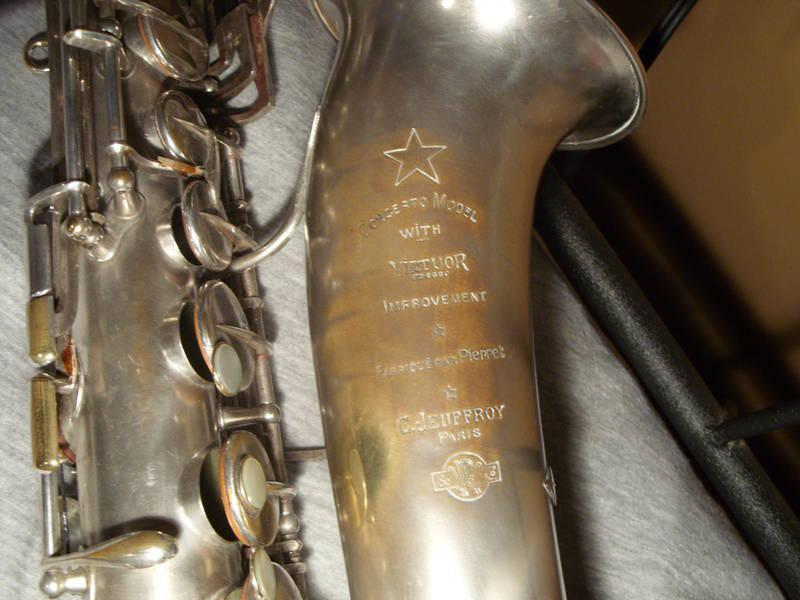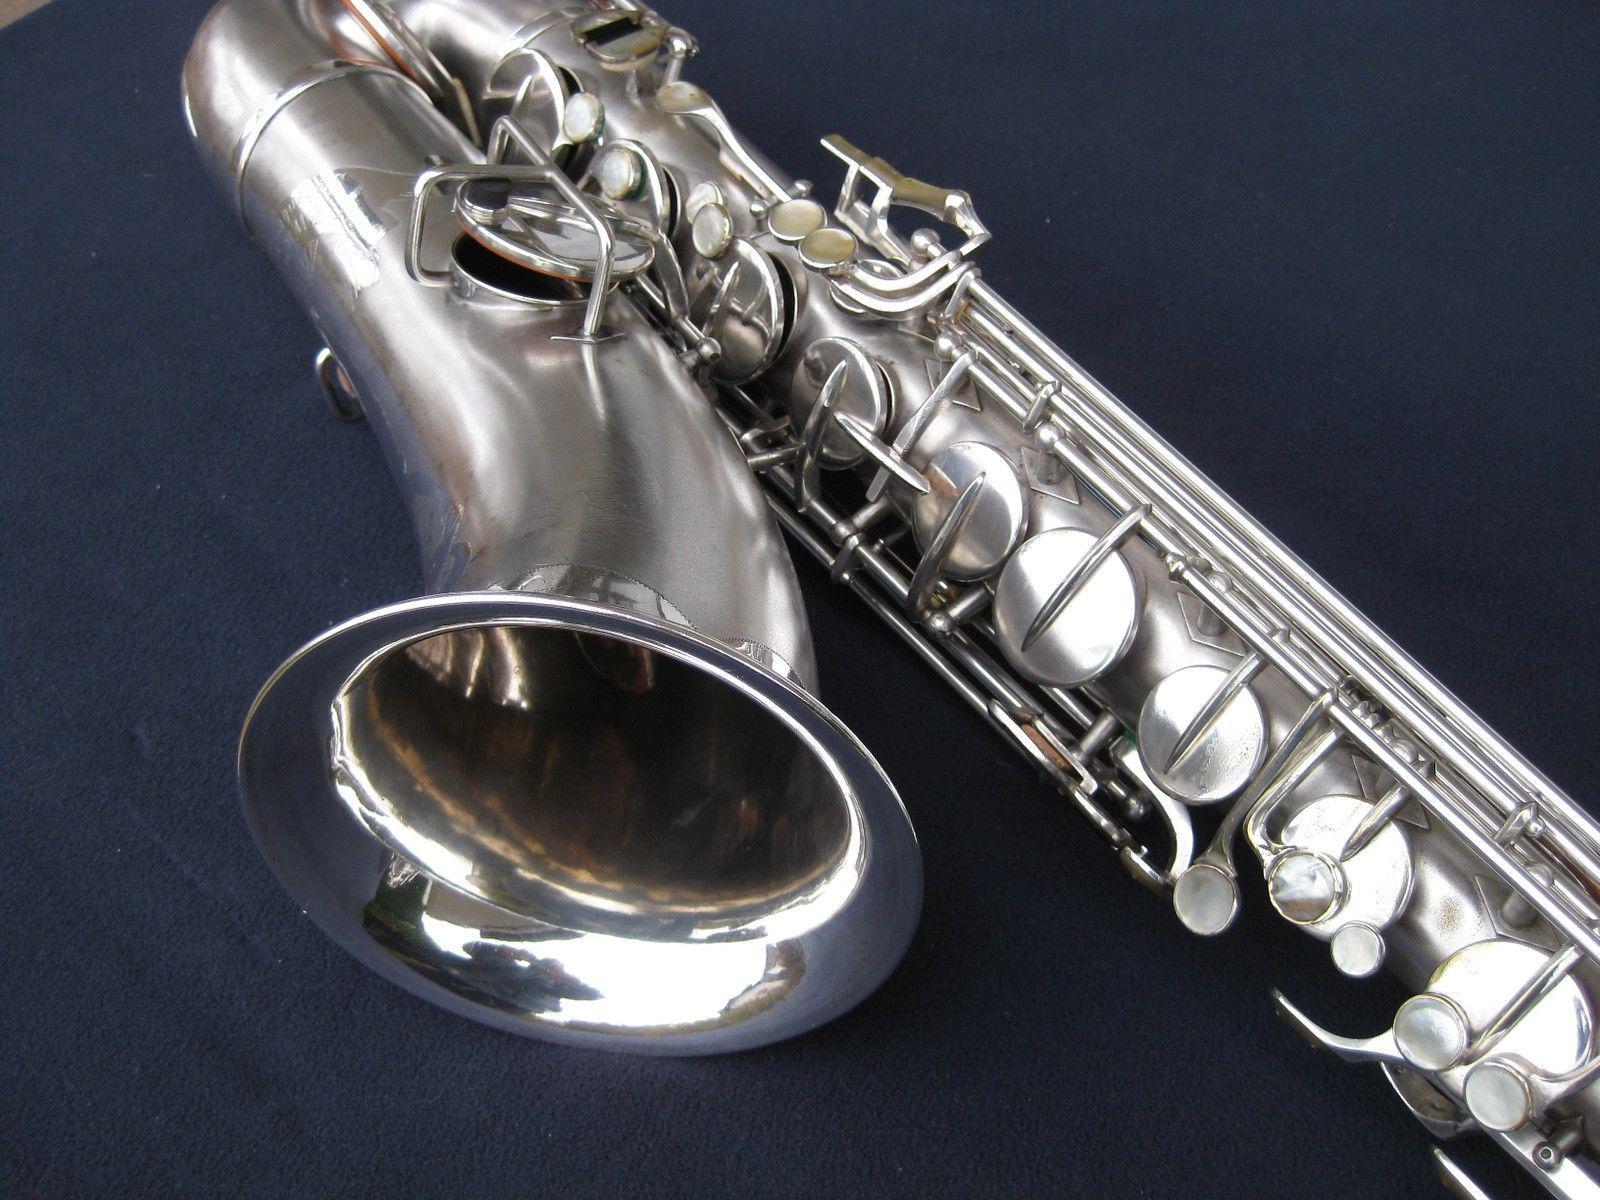The first image is the image on the left, the second image is the image on the right. Considering the images on both sides, is "The sax in the image on the left has etching on it." valid? Answer yes or no. Yes. The first image is the image on the left, the second image is the image on the right. For the images displayed, is the sentence "The left image shows a saxophone displayed in front of an open black case, and the right image features a saxophone displayed without a case." factually correct? Answer yes or no. No. 